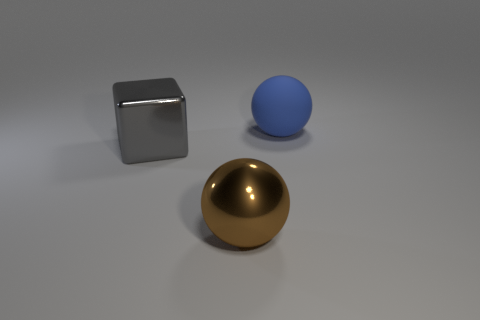What number of other things are made of the same material as the gray thing?
Provide a succinct answer. 1. How big is the brown metallic ball?
Provide a succinct answer. Large. Are there any other big things that have the same shape as the gray object?
Ensure brevity in your answer.  No. How many objects are either small gray metal blocks or things to the right of the big gray thing?
Keep it short and to the point. 2. What color is the big sphere behind the cube?
Offer a very short reply. Blue. Are there any metal balls that have the same size as the brown metal thing?
Provide a succinct answer. No. How many spheres are behind the large metal thing in front of the block?
Ensure brevity in your answer.  1. What is the material of the blue thing?
Provide a short and direct response. Rubber. What number of large gray metallic blocks are behind the blue matte thing?
Offer a very short reply. 0. Does the large metallic block have the same color as the matte sphere?
Provide a succinct answer. No. 